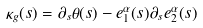<formula> <loc_0><loc_0><loc_500><loc_500>\kappa _ { g } ( s ) = \partial _ { s } \theta ( s ) - e _ { 1 } ^ { \alpha } ( s ) \partial _ { s } e _ { 2 } ^ { \alpha } ( s )</formula> 